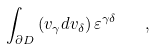Convert formula to latex. <formula><loc_0><loc_0><loc_500><loc_500>\int _ { \partial D } \left ( v _ { \gamma } d v _ { \delta } \right ) \varepsilon ^ { \gamma \delta } \quad ,</formula> 